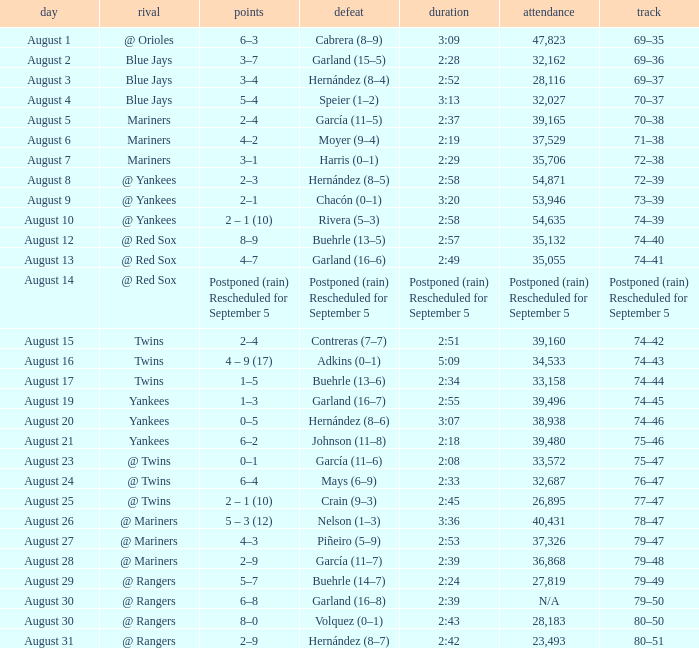Who lost with a time of 2:42? Hernández (8–7). 